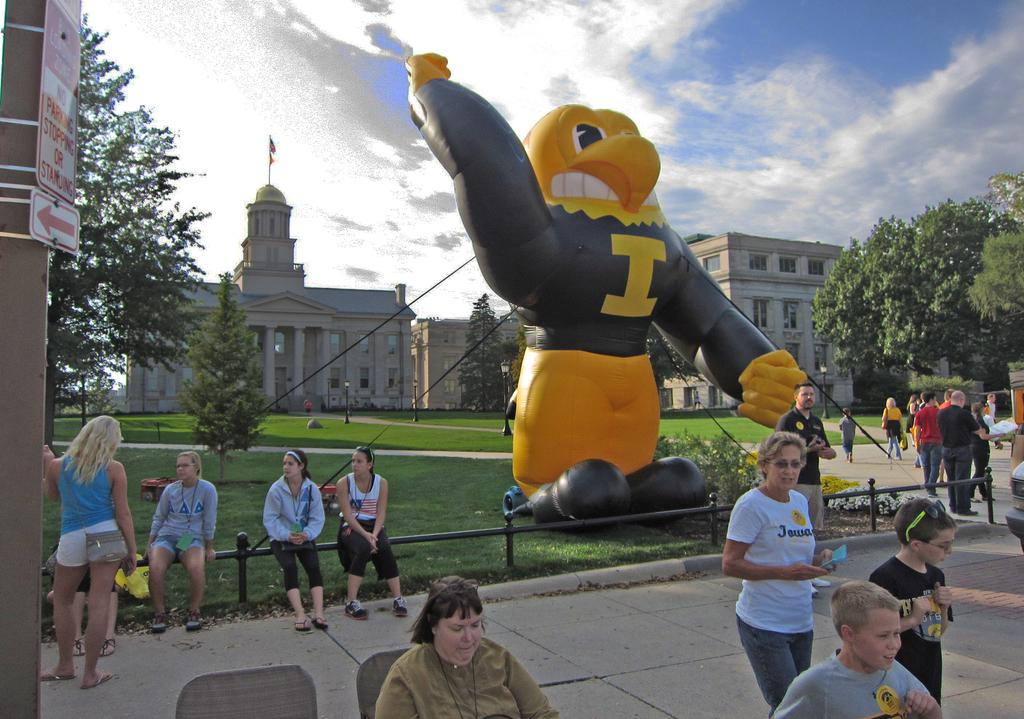<image>
Share a concise interpretation of the image provided. Large blow up balloon of a mascot with the letter I on it's chest. 